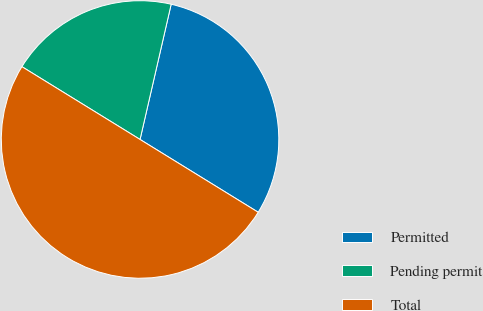<chart> <loc_0><loc_0><loc_500><loc_500><pie_chart><fcel>Permitted<fcel>Pending permit<fcel>Total<nl><fcel>30.19%<fcel>19.81%<fcel>50.0%<nl></chart> 